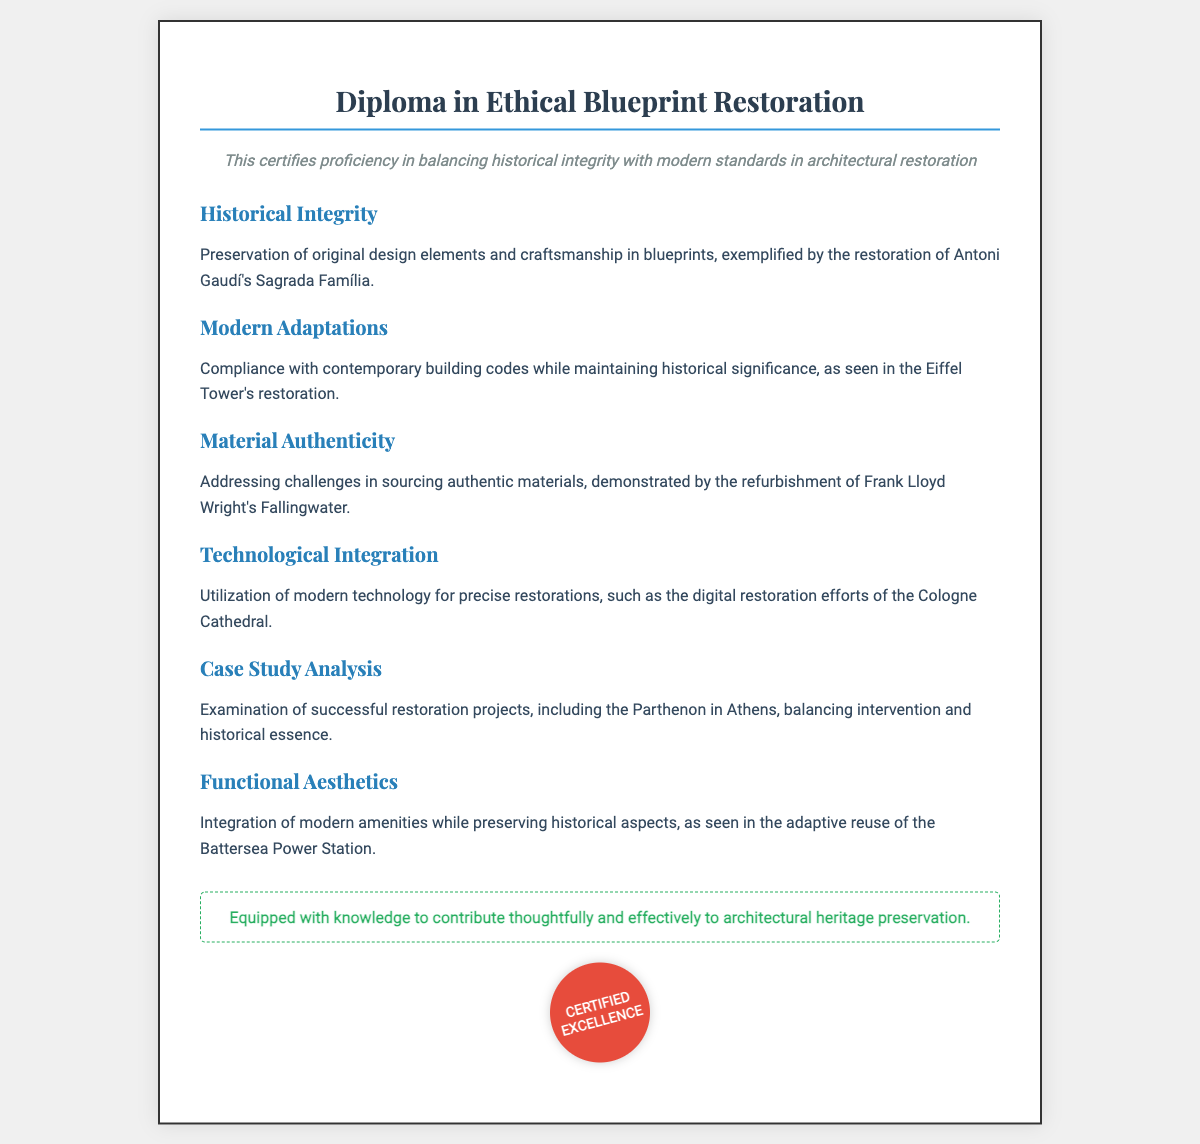What is the title of the diploma? The title of the diploma can be found at the top of the document.
Answer: Diploma in Ethical Blueprint Restoration What is the first section of the diploma about? The first section discusses the preservation of original design elements and craftsmanship.
Answer: Historical Integrity Which architectural project exemplifies the concept of Material Authenticity? The document mentions a specific architectural project related to Material Authenticity.
Answer: Fallingwater What does the conclusion state about the knowledge gained? The conclusion summarizes the purpose of the diploma and the knowledge imparted to the recipient.
Answer: Contribute thoughtfully and effectively to architectural heritage preservation How many sections are there in the diploma? The sections listed in the document indicate the variety of topics covered in the diploma.
Answer: Six 